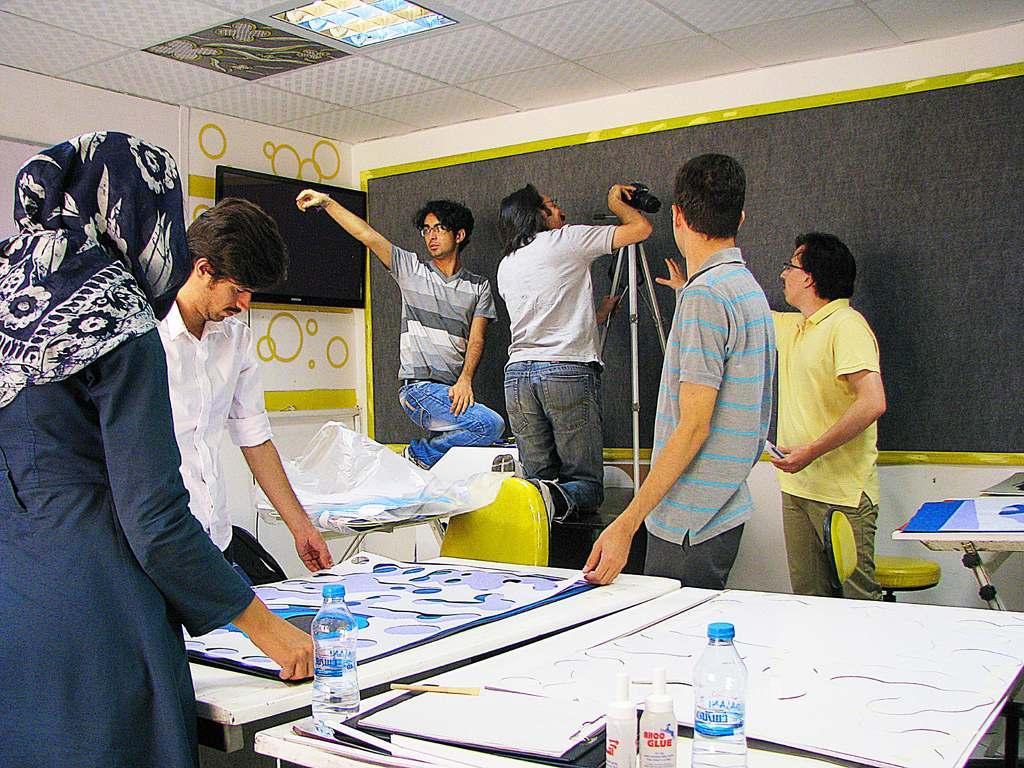Please provide a concise description of this image. On the left side, there is a woman, holding a chart which is on the white color table and standing. Beside this table, there are bottles, a chart and books on another table. In the background, there are persons working, there is a black color board, a monitor attached to the wall and there is a light attached to the roof. 